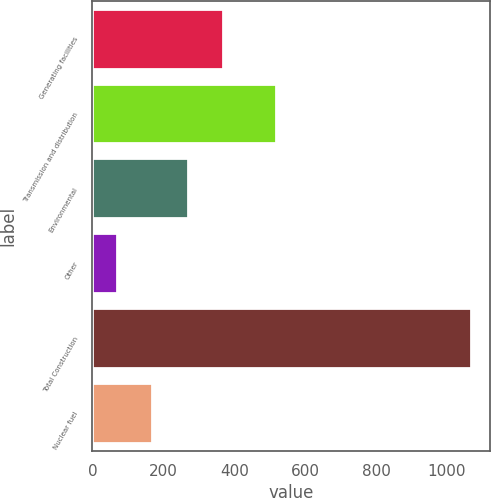<chart> <loc_0><loc_0><loc_500><loc_500><bar_chart><fcel>Generating facilities<fcel>Transmission and distribution<fcel>Environmental<fcel>Other<fcel>Total Construction<fcel>Nuclear fuel<nl><fcel>368.4<fcel>518<fcel>268.6<fcel>69<fcel>1067<fcel>168.8<nl></chart> 